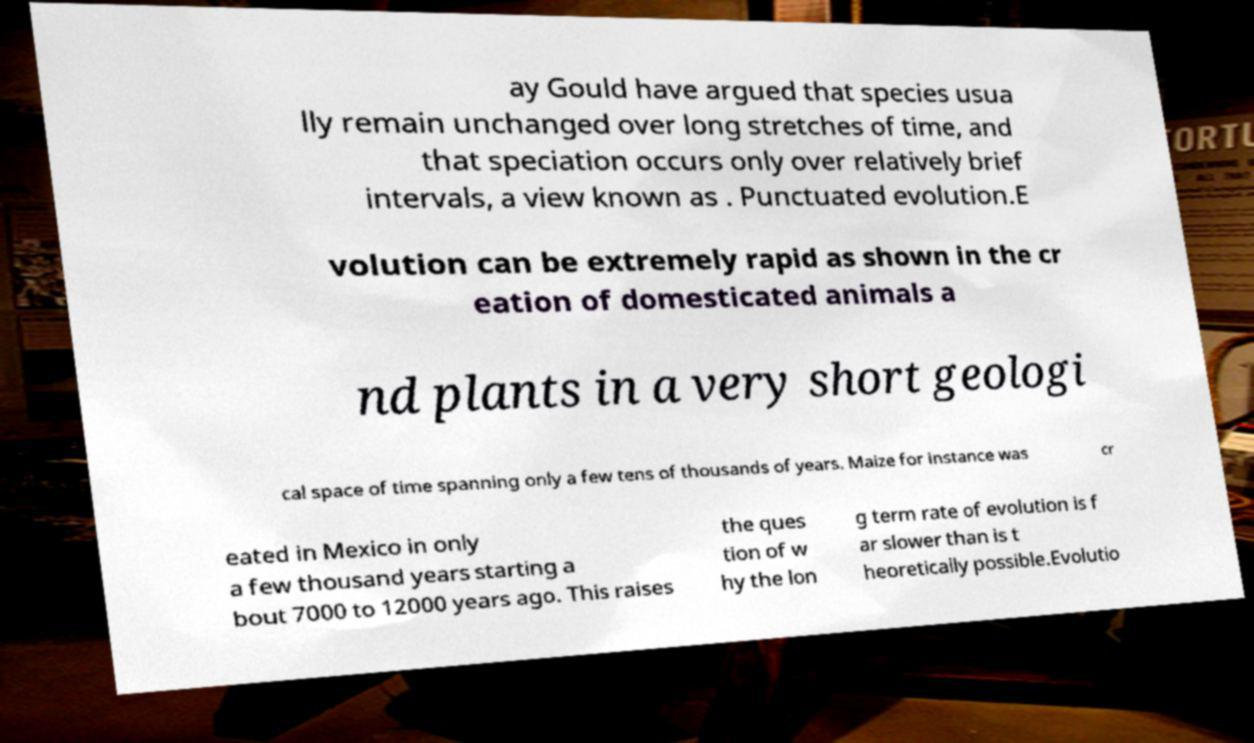Could you assist in decoding the text presented in this image and type it out clearly? ay Gould have argued that species usua lly remain unchanged over long stretches of time, and that speciation occurs only over relatively brief intervals, a view known as . Punctuated evolution.E volution can be extremely rapid as shown in the cr eation of domesticated animals a nd plants in a very short geologi cal space of time spanning only a few tens of thousands of years. Maize for instance was cr eated in Mexico in only a few thousand years starting a bout 7000 to 12000 years ago. This raises the ques tion of w hy the lon g term rate of evolution is f ar slower than is t heoretically possible.Evolutio 